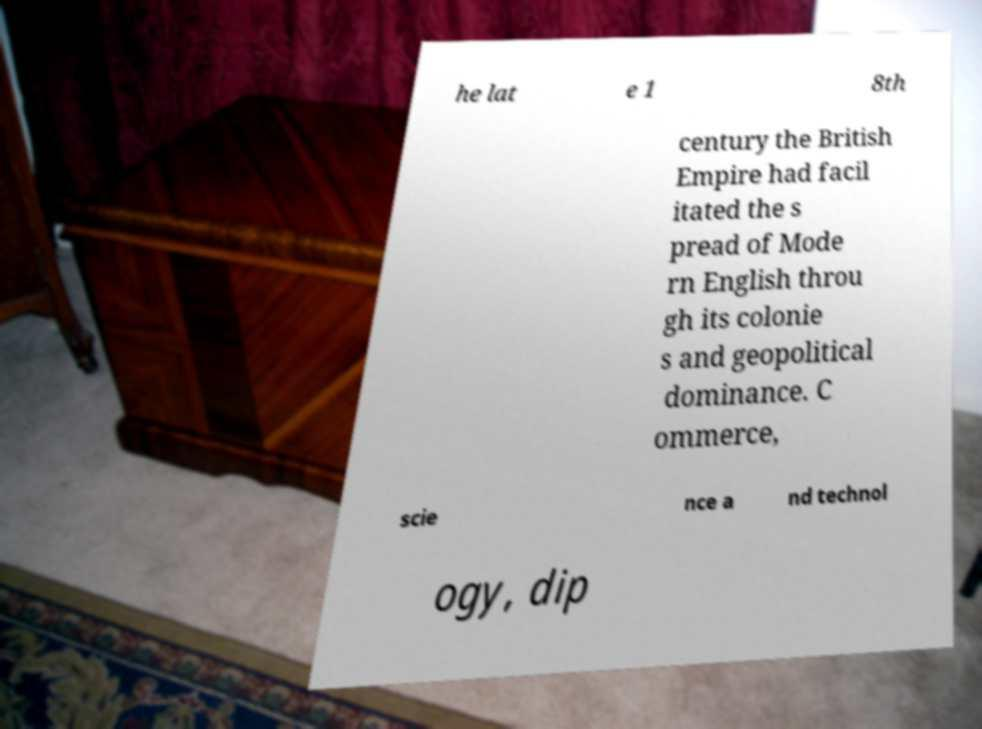Could you extract and type out the text from this image? he lat e 1 8th century the British Empire had facil itated the s pread of Mode rn English throu gh its colonie s and geopolitical dominance. C ommerce, scie nce a nd technol ogy, dip 